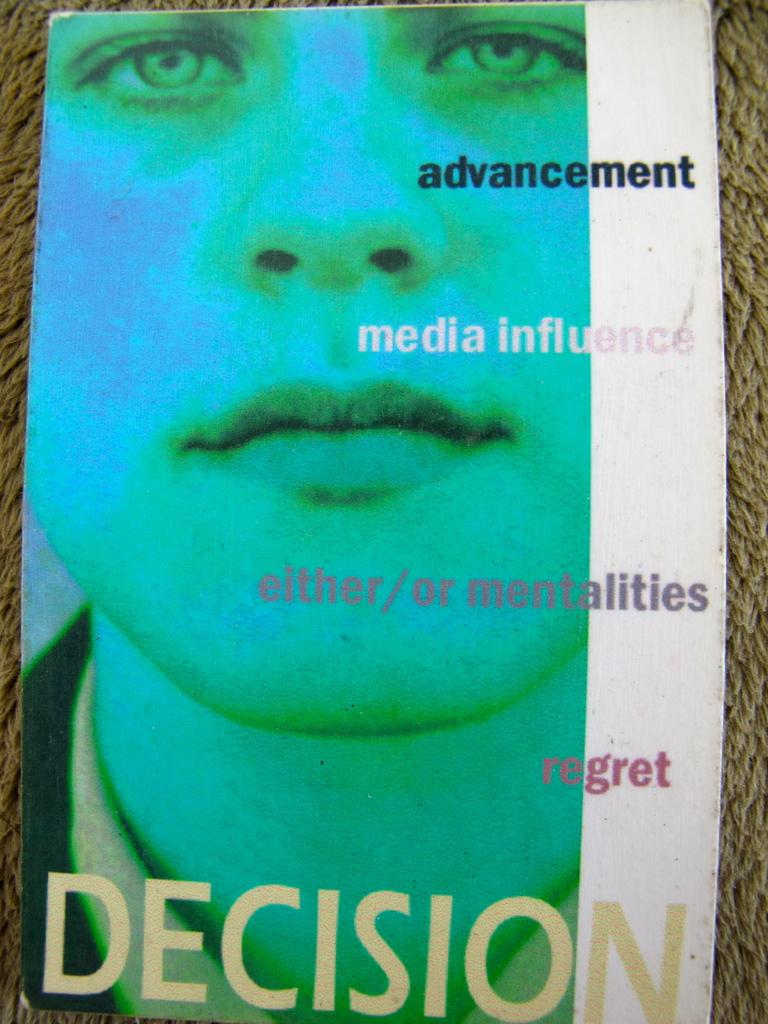What is the main subject of the image? The main subject of the image is the cover page of a book. What can be seen on the cover page? There is a face of a person on the cover page. Is there any text on the cover page? Yes, there is text on the cover page. What degree does the person on the cover page hold? There is no information about the person's degree on the cover page, as it only shows their face and text. 